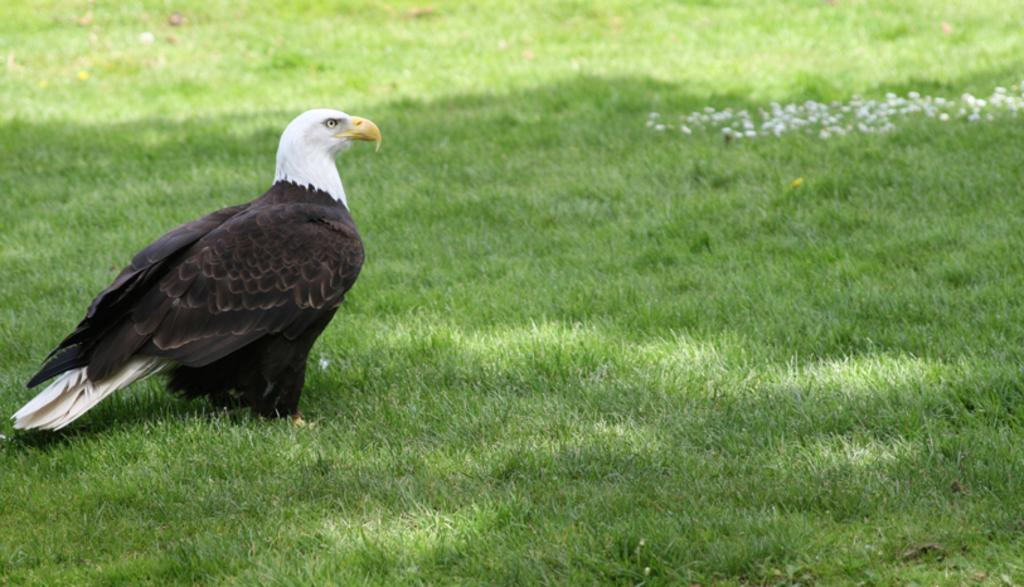What type of vegetation is present on the ground in the image? There is grass on the ground in the image. What animal can be seen in the image? There is a bird on the left side of the image. In which direction is the bird facing? The bird is facing towards the right side of the image. What type of music is the bird playing in the image? There is no music or indication of music in the image; it features a bird facing towards the right side of the image. 